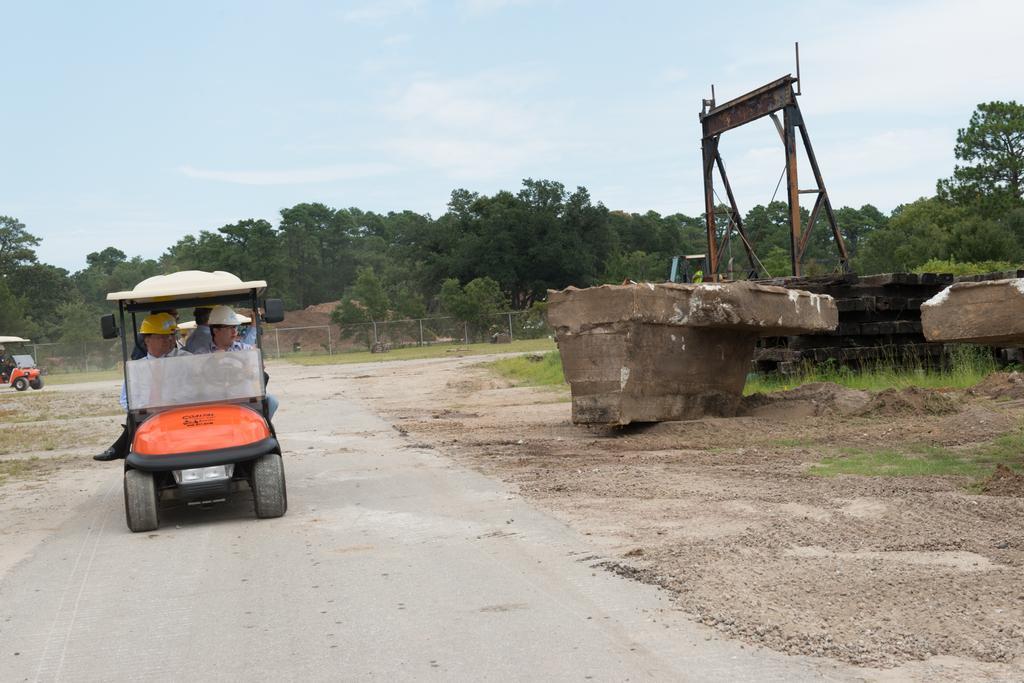Could you give a brief overview of what you see in this image? In this image there is a vehicle on the road. Few persons are sitting inside the vehicle. They are wearing caps. Right side there are few objects. Behind there are metal rods. Left side there is a vehicle having a person sitting inside it. Behind it there is a fence. Behind it there are few trees. Top of the image there is sky. 